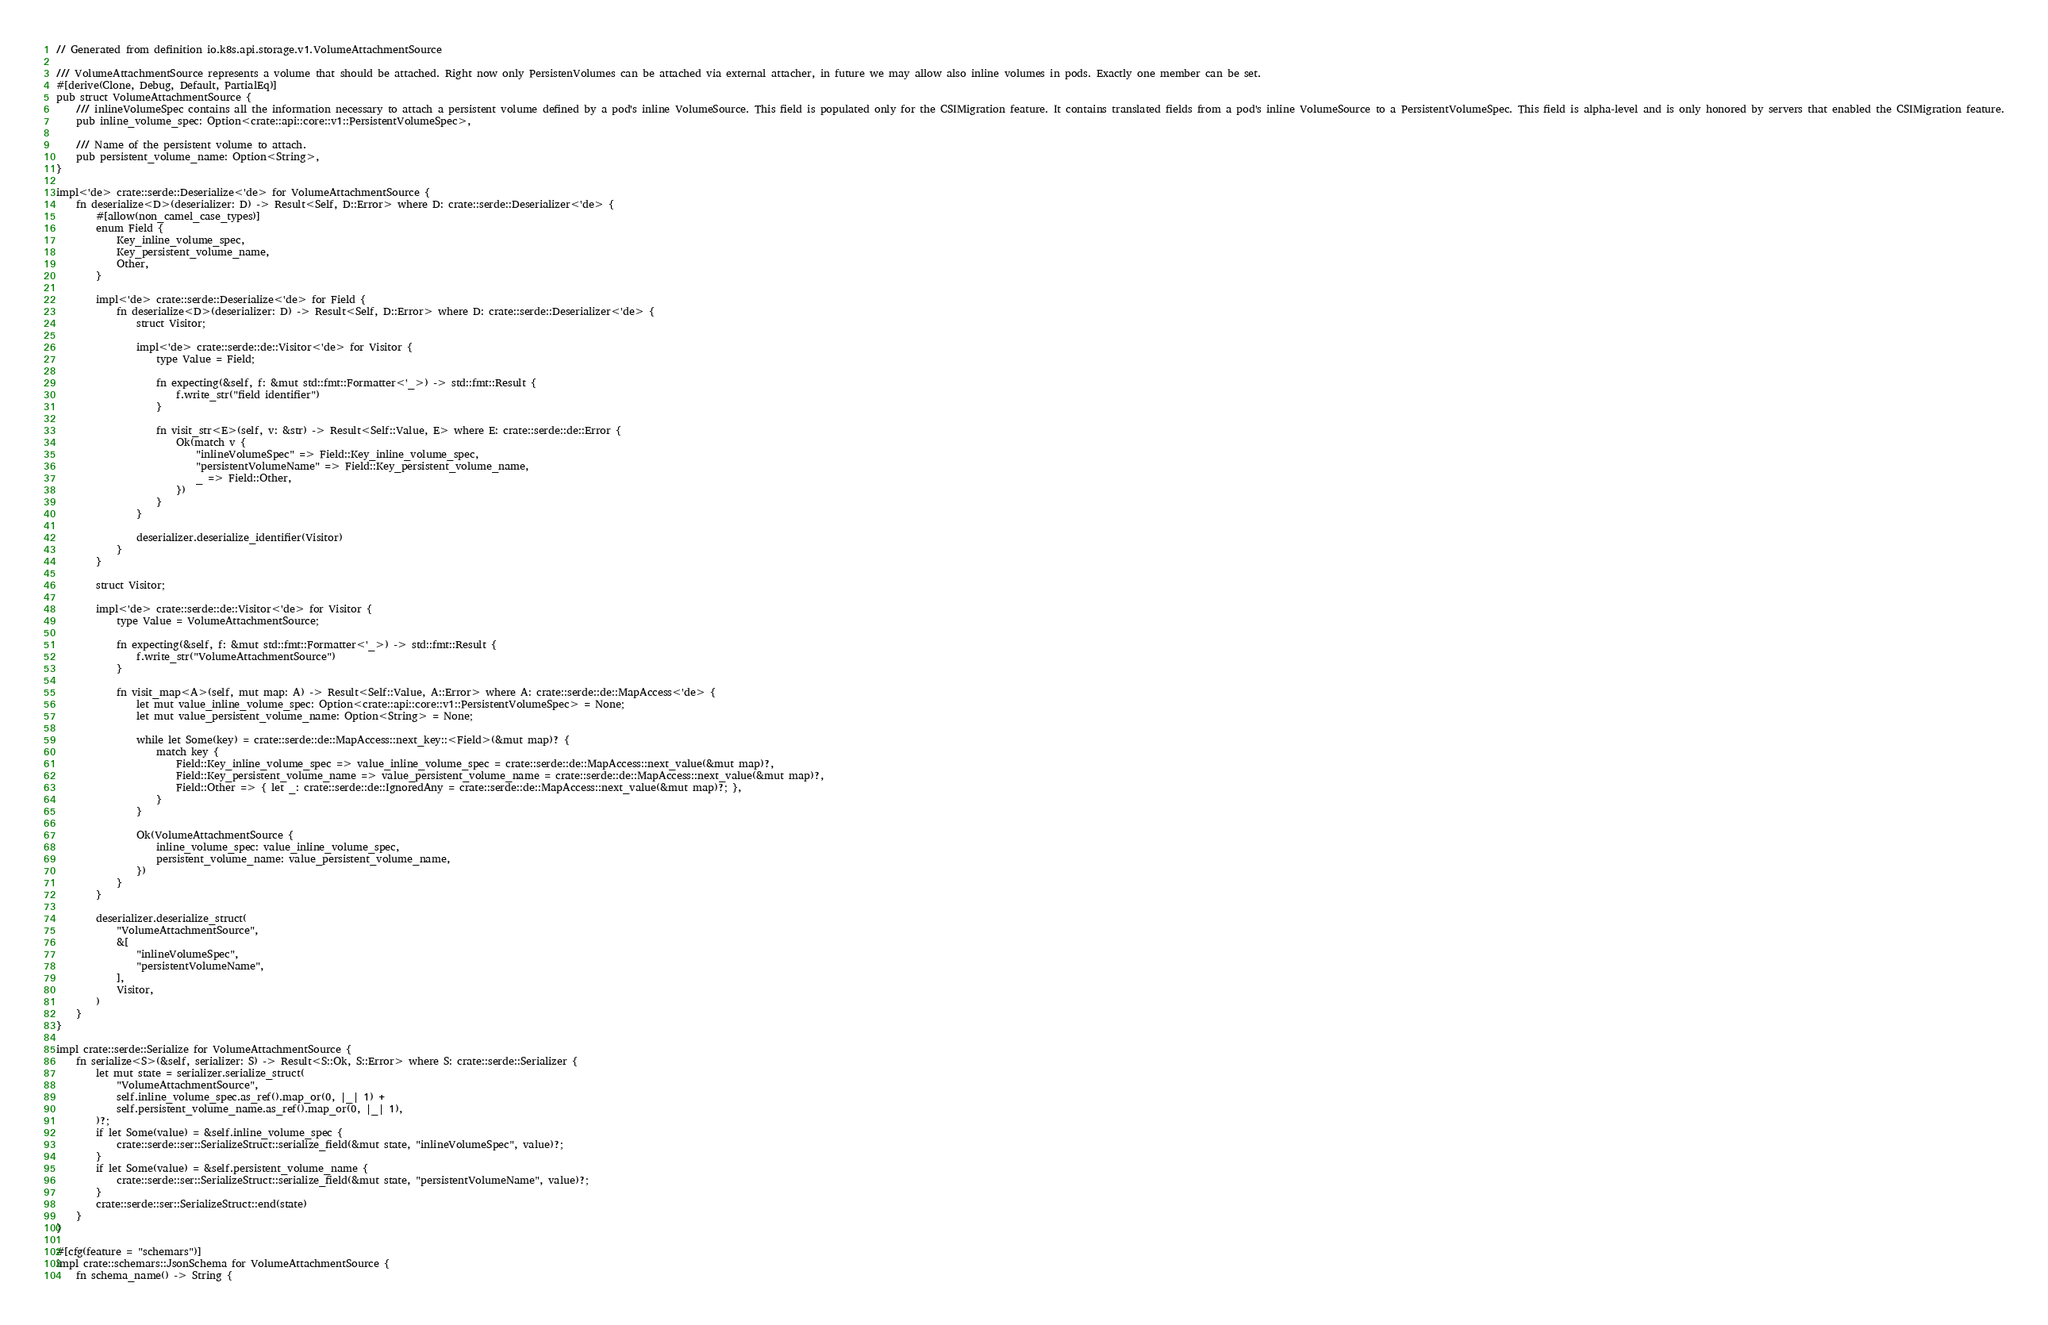Convert code to text. <code><loc_0><loc_0><loc_500><loc_500><_Rust_>// Generated from definition io.k8s.api.storage.v1.VolumeAttachmentSource

/// VolumeAttachmentSource represents a volume that should be attached. Right now only PersistenVolumes can be attached via external attacher, in future we may allow also inline volumes in pods. Exactly one member can be set.
#[derive(Clone, Debug, Default, PartialEq)]
pub struct VolumeAttachmentSource {
    /// inlineVolumeSpec contains all the information necessary to attach a persistent volume defined by a pod's inline VolumeSource. This field is populated only for the CSIMigration feature. It contains translated fields from a pod's inline VolumeSource to a PersistentVolumeSpec. This field is alpha-level and is only honored by servers that enabled the CSIMigration feature.
    pub inline_volume_spec: Option<crate::api::core::v1::PersistentVolumeSpec>,

    /// Name of the persistent volume to attach.
    pub persistent_volume_name: Option<String>,
}

impl<'de> crate::serde::Deserialize<'de> for VolumeAttachmentSource {
    fn deserialize<D>(deserializer: D) -> Result<Self, D::Error> where D: crate::serde::Deserializer<'de> {
        #[allow(non_camel_case_types)]
        enum Field {
            Key_inline_volume_spec,
            Key_persistent_volume_name,
            Other,
        }

        impl<'de> crate::serde::Deserialize<'de> for Field {
            fn deserialize<D>(deserializer: D) -> Result<Self, D::Error> where D: crate::serde::Deserializer<'de> {
                struct Visitor;

                impl<'de> crate::serde::de::Visitor<'de> for Visitor {
                    type Value = Field;

                    fn expecting(&self, f: &mut std::fmt::Formatter<'_>) -> std::fmt::Result {
                        f.write_str("field identifier")
                    }

                    fn visit_str<E>(self, v: &str) -> Result<Self::Value, E> where E: crate::serde::de::Error {
                        Ok(match v {
                            "inlineVolumeSpec" => Field::Key_inline_volume_spec,
                            "persistentVolumeName" => Field::Key_persistent_volume_name,
                            _ => Field::Other,
                        })
                    }
                }

                deserializer.deserialize_identifier(Visitor)
            }
        }

        struct Visitor;

        impl<'de> crate::serde::de::Visitor<'de> for Visitor {
            type Value = VolumeAttachmentSource;

            fn expecting(&self, f: &mut std::fmt::Formatter<'_>) -> std::fmt::Result {
                f.write_str("VolumeAttachmentSource")
            }

            fn visit_map<A>(self, mut map: A) -> Result<Self::Value, A::Error> where A: crate::serde::de::MapAccess<'de> {
                let mut value_inline_volume_spec: Option<crate::api::core::v1::PersistentVolumeSpec> = None;
                let mut value_persistent_volume_name: Option<String> = None;

                while let Some(key) = crate::serde::de::MapAccess::next_key::<Field>(&mut map)? {
                    match key {
                        Field::Key_inline_volume_spec => value_inline_volume_spec = crate::serde::de::MapAccess::next_value(&mut map)?,
                        Field::Key_persistent_volume_name => value_persistent_volume_name = crate::serde::de::MapAccess::next_value(&mut map)?,
                        Field::Other => { let _: crate::serde::de::IgnoredAny = crate::serde::de::MapAccess::next_value(&mut map)?; },
                    }
                }

                Ok(VolumeAttachmentSource {
                    inline_volume_spec: value_inline_volume_spec,
                    persistent_volume_name: value_persistent_volume_name,
                })
            }
        }

        deserializer.deserialize_struct(
            "VolumeAttachmentSource",
            &[
                "inlineVolumeSpec",
                "persistentVolumeName",
            ],
            Visitor,
        )
    }
}

impl crate::serde::Serialize for VolumeAttachmentSource {
    fn serialize<S>(&self, serializer: S) -> Result<S::Ok, S::Error> where S: crate::serde::Serializer {
        let mut state = serializer.serialize_struct(
            "VolumeAttachmentSource",
            self.inline_volume_spec.as_ref().map_or(0, |_| 1) +
            self.persistent_volume_name.as_ref().map_or(0, |_| 1),
        )?;
        if let Some(value) = &self.inline_volume_spec {
            crate::serde::ser::SerializeStruct::serialize_field(&mut state, "inlineVolumeSpec", value)?;
        }
        if let Some(value) = &self.persistent_volume_name {
            crate::serde::ser::SerializeStruct::serialize_field(&mut state, "persistentVolumeName", value)?;
        }
        crate::serde::ser::SerializeStruct::end(state)
    }
}

#[cfg(feature = "schemars")]
impl crate::schemars::JsonSchema for VolumeAttachmentSource {
    fn schema_name() -> String {</code> 